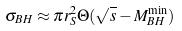<formula> <loc_0><loc_0><loc_500><loc_500>\sigma _ { B H } \approx \pi r _ { S } ^ { 2 } \Theta ( \sqrt { s } - M _ { B H } ^ { \min } )</formula> 